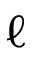Convert formula to latex. <formula><loc_0><loc_0><loc_500><loc_500>\ell</formula> 